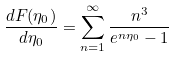Convert formula to latex. <formula><loc_0><loc_0><loc_500><loc_500>\frac { d F ( \eta _ { 0 } ) } { d \eta _ { 0 } } = \sum _ { n = 1 } ^ { \infty } \frac { n ^ { 3 } } { e ^ { n \eta _ { 0 } } - 1 }</formula> 